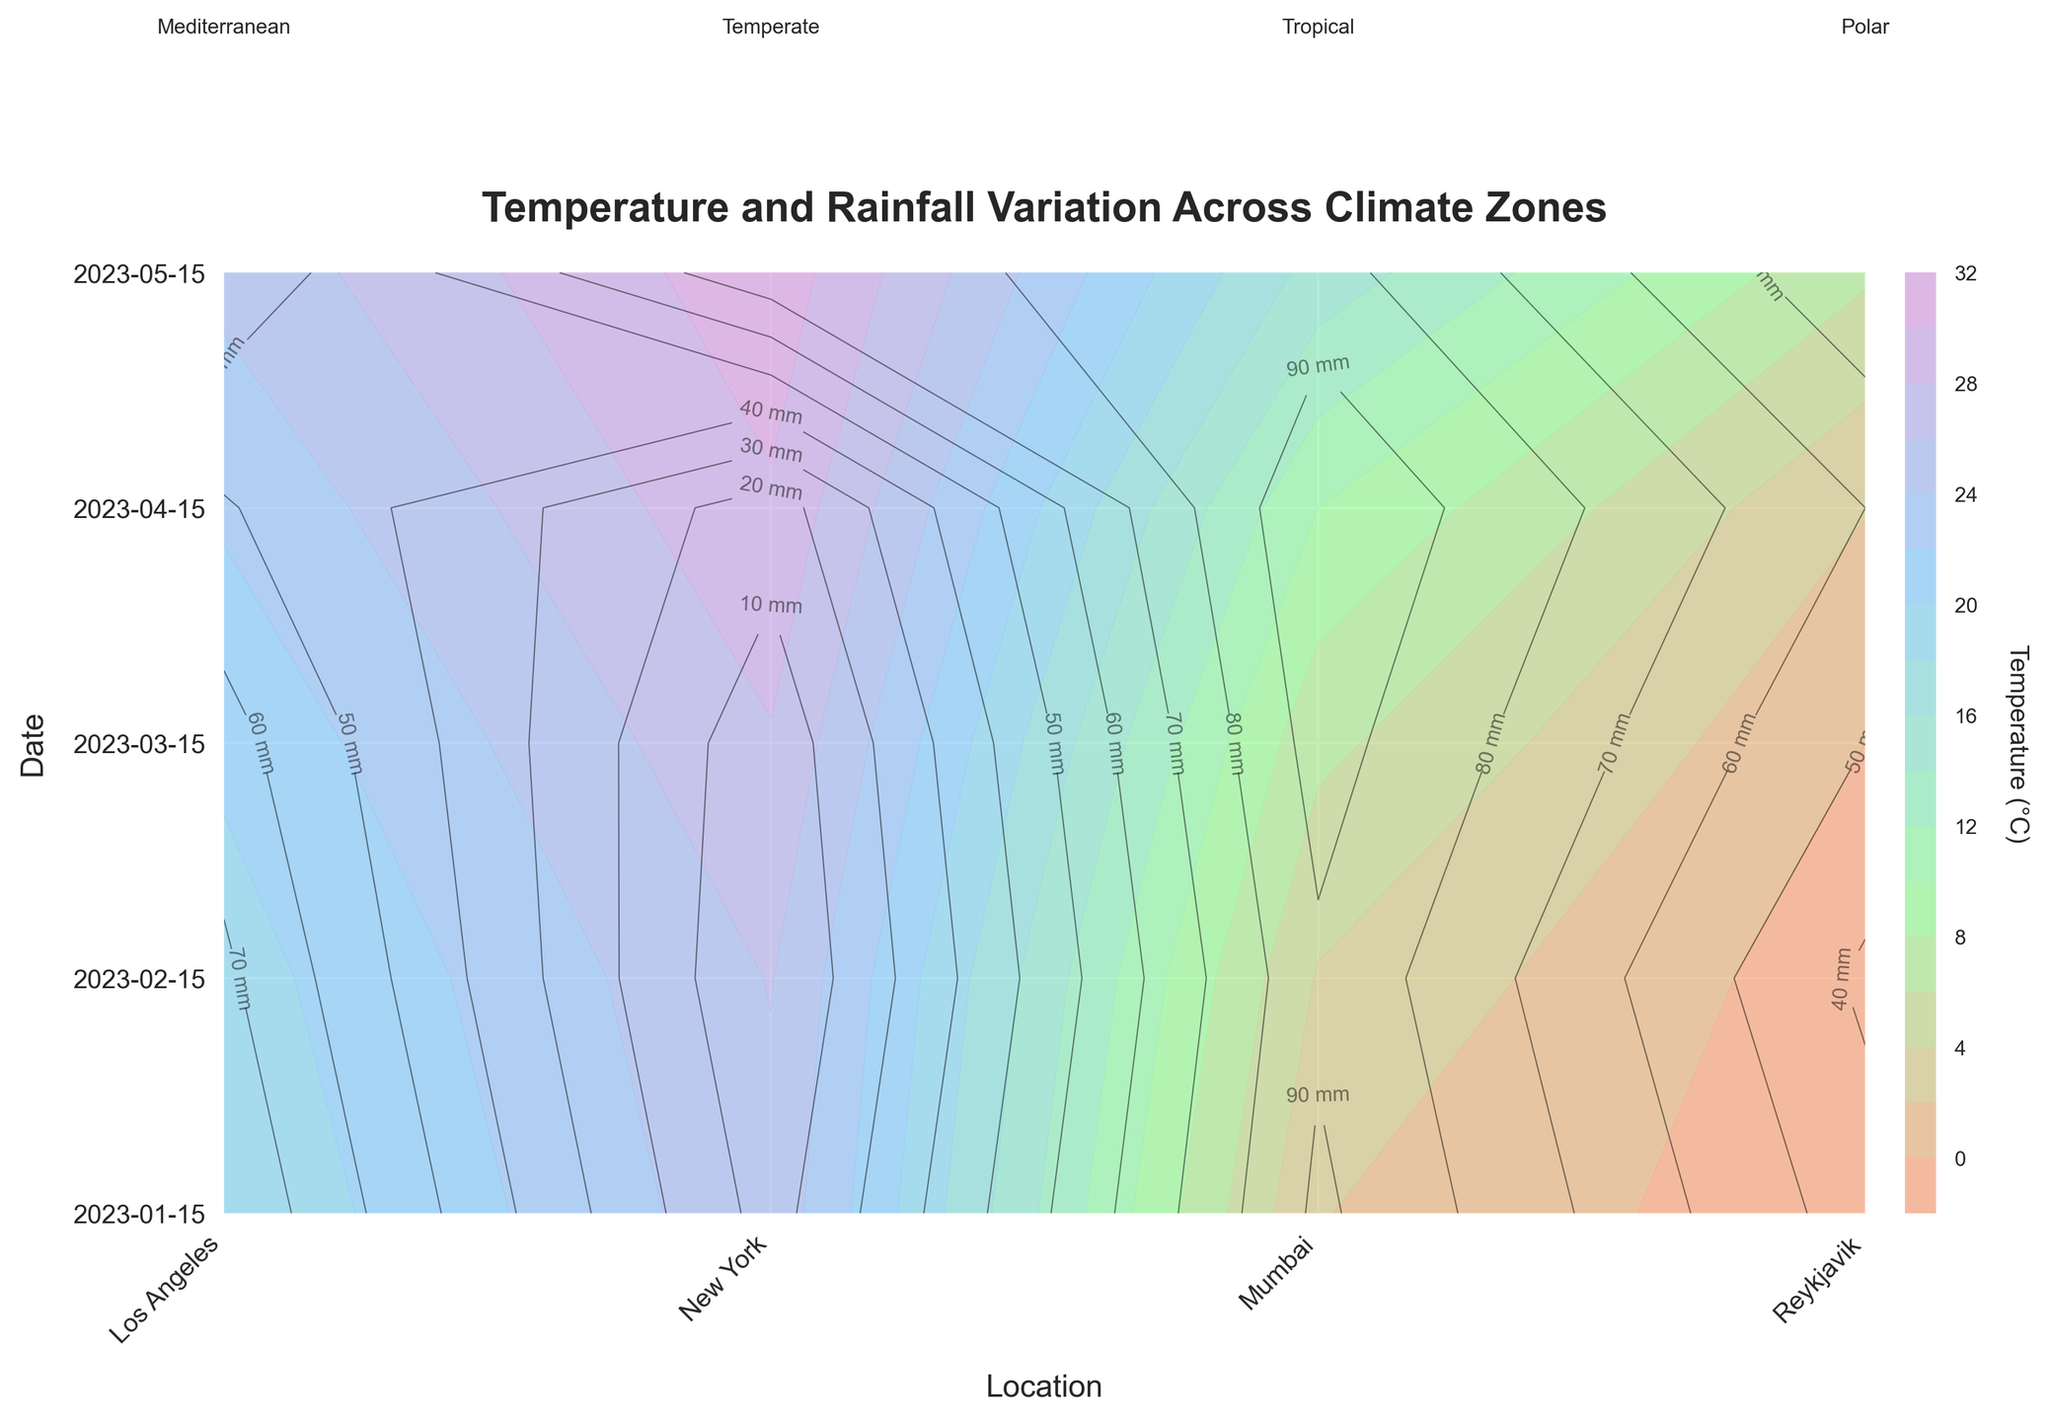How many locations are represented in the figure? First, look at the x-axis where the locations are labeled. Count the number of labels to identify the number of locations. In this case, there are labels for Los Angeles, New York, Mumbai, and Reykjavik.
Answer: 4 What's the title of the figure? The title of the figure is usually displayed at the top of the plot. In this case, it is "Temperature and Rainfall Variation Across Climate Zones."
Answer: Temperature and Rainfall Variation Across Climate Zones Which location experiences the highest average temperature? Inspect the contour levels and values on the x-axis corresponding to each location. Compare the temperature contours for all four locations across all dates. Mumbai, marked as 'Tropical', shows the highest temperature consistently.
Answer: Mumbai What is the average temperature in Los Angeles in January and February? Identify the corresponding contours for Los Angeles for January and February on the y-axis, locate where they intersect with the temperature contours, and approximate the average values. January shows about 18.3°C and February about 19.1°C. Average these two values: (18.3 + 19.1) / 2 = 18.7°C.
Answer: 18.7°C Which month had the highest rainfall in New York? Look at the contour labels for rainfall on the y-axis for New York and check for the highest contour label in millimeters. The highest rainfall for New York appears in April with about 99mm of rain.
Answer: April Which climate zone is indicated next to the label Reykjavik? Locate Reykjavik on the x-axis and check the text annotation above the figure. The climate zone for Reykjavik is 'Polar'.
Answer: Polar Does Los Angeles experience more rainfall in March or April? Compare the rainfall contours for Los Angeles in March and April. The figure shows that March has about 64mm of rain while April has 51mm.
Answer: March Which location has the least variation in temperature over the months shown? Observe the temperature contours for each location and look for the one with the most consistent (least variable) temperatures across different dates. Reykjavik shows the least variation, with temperatures closely clustered around 0°C.
Answer: Reykjavik What color represents the highest temperature in the colormap? Look at the color gradient used in the temperature contours. The highest temperature is represented by the color at the end of the gradient. In this case, it is likely represented by the warmest color, which is typically #FFA07A (a shade of orange).
Answer: Orange Is there any month where Reykjavik has a temperature above zero? Trace Reykjavik's contour levels on the y-axis and examine whether any contours are above zero degrees. In April, Reykjavik's temperature is slightly above zero (2.1°C).
Answer: April 